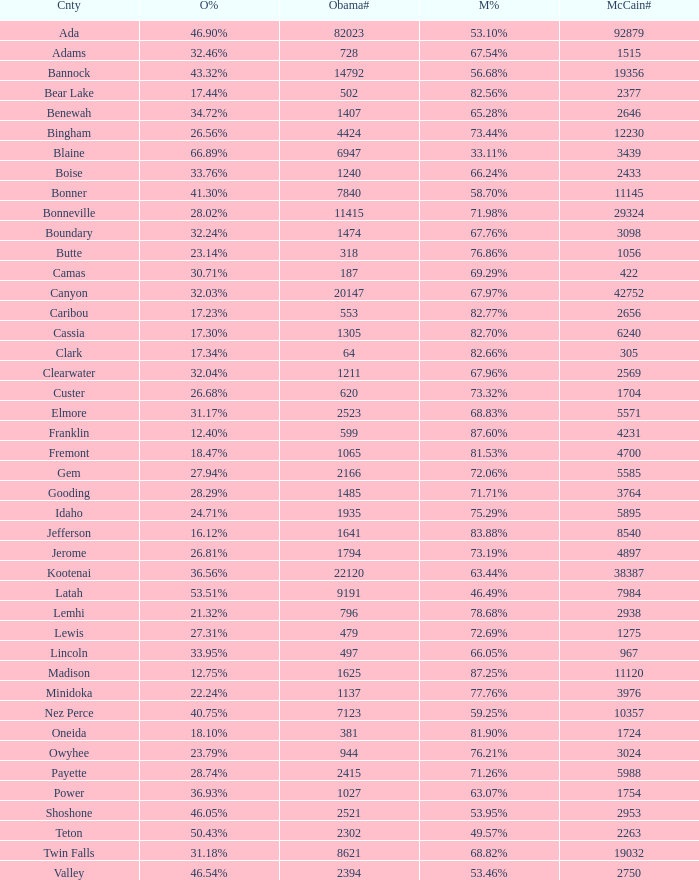What is the McCain vote percentage in Jerome county? 73.19%. 